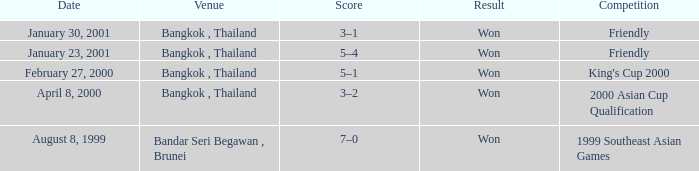What was the score from the king's cup 2000? 5–1. 